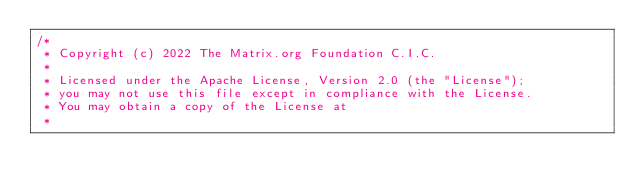Convert code to text. <code><loc_0><loc_0><loc_500><loc_500><_Kotlin_>/*
 * Copyright (c) 2022 The Matrix.org Foundation C.I.C.
 *
 * Licensed under the Apache License, Version 2.0 (the "License");
 * you may not use this file except in compliance with the License.
 * You may obtain a copy of the License at
 *</code> 